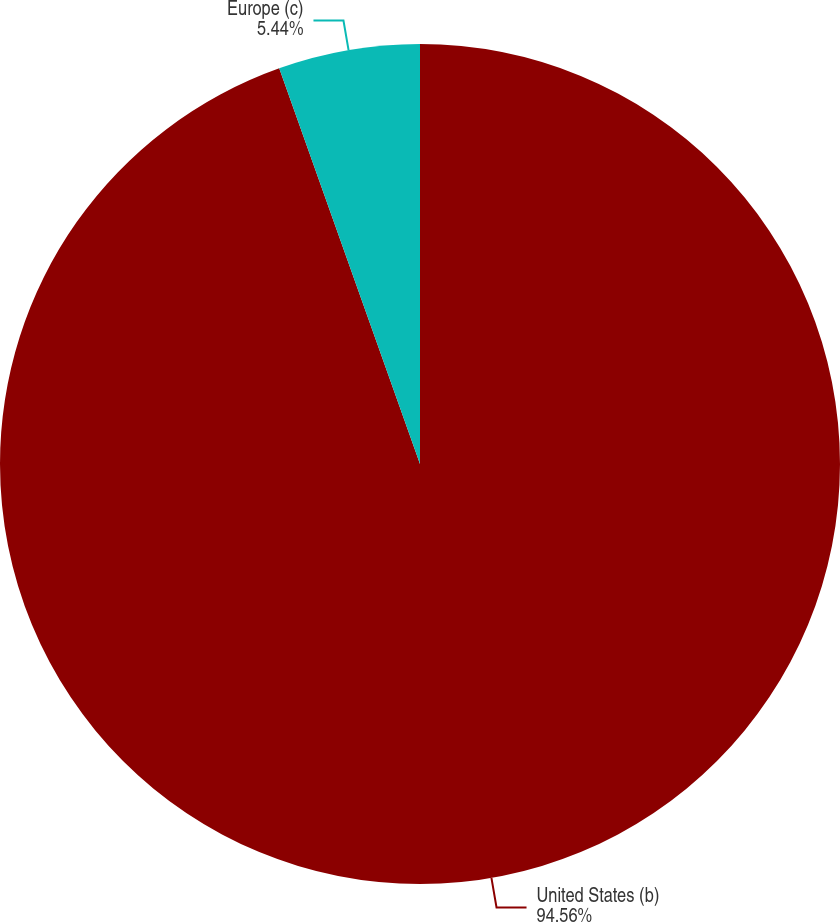<chart> <loc_0><loc_0><loc_500><loc_500><pie_chart><fcel>United States (b)<fcel>Europe (c)<nl><fcel>94.56%<fcel>5.44%<nl></chart> 